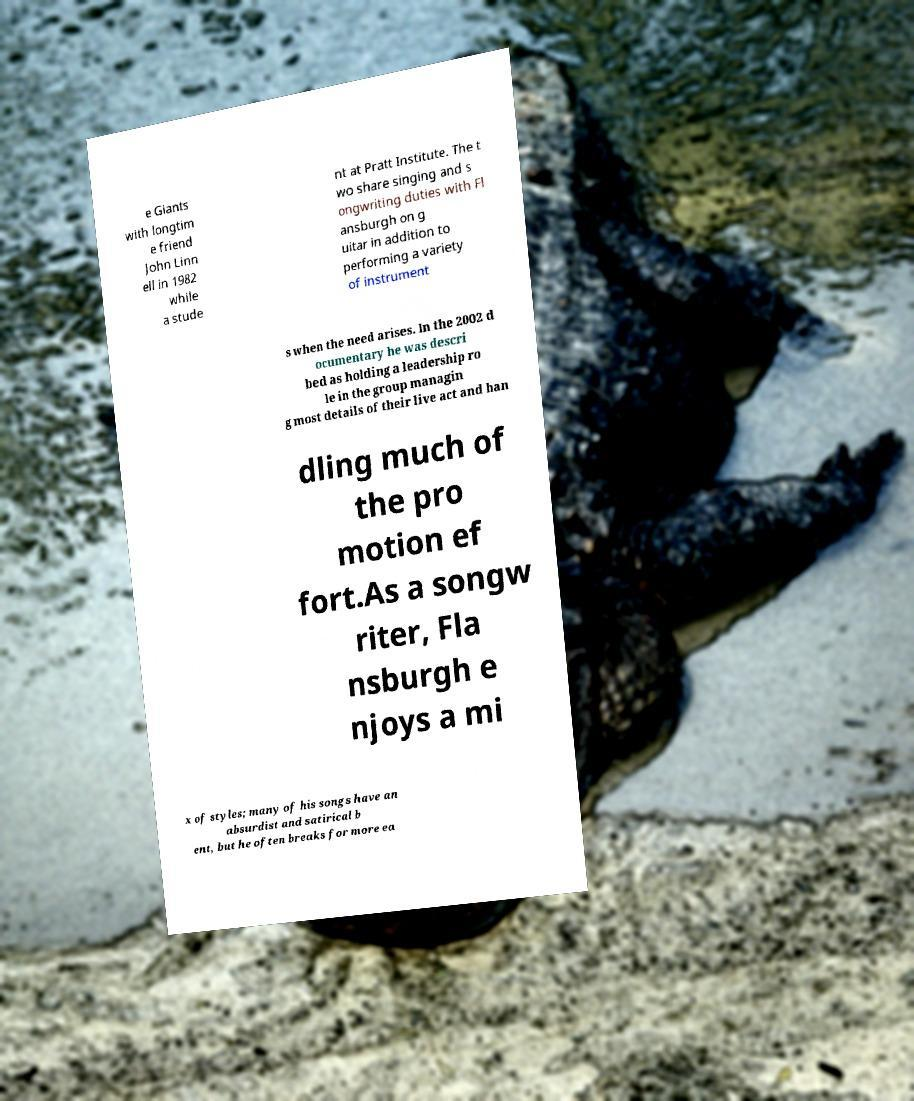I need the written content from this picture converted into text. Can you do that? e Giants with longtim e friend John Linn ell in 1982 while a stude nt at Pratt Institute. The t wo share singing and s ongwriting duties with Fl ansburgh on g uitar in addition to performing a variety of instrument s when the need arises. In the 2002 d ocumentary he was descri bed as holding a leadership ro le in the group managin g most details of their live act and han dling much of the pro motion ef fort.As a songw riter, Fla nsburgh e njoys a mi x of styles; many of his songs have an absurdist and satirical b ent, but he often breaks for more ea 